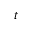Convert formula to latex. <formula><loc_0><loc_0><loc_500><loc_500>t</formula> 